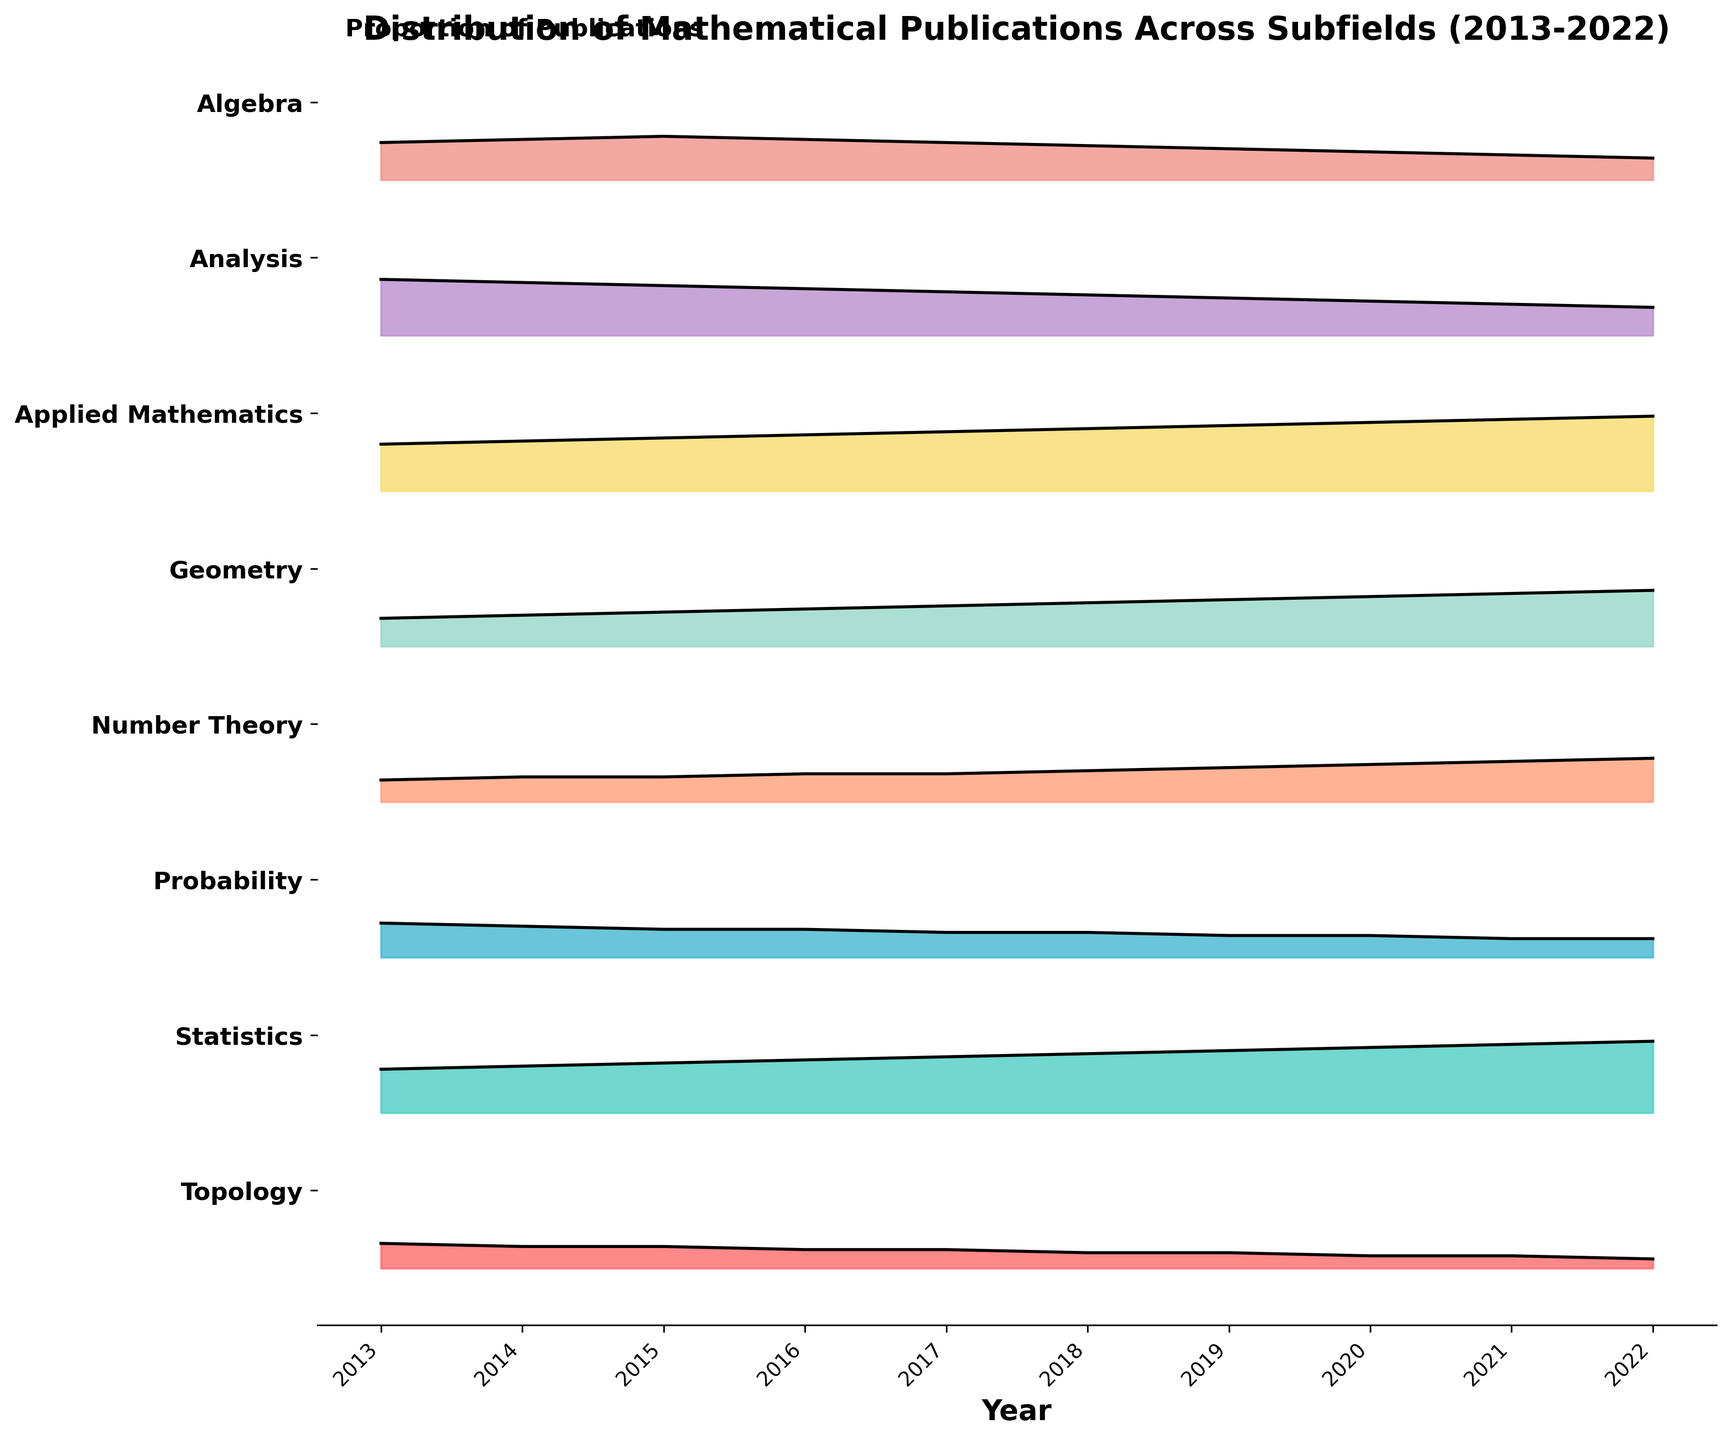What's the title of the plot? The title of the plot is typically displayed at the top of the figure. Here, it is "Distribution of Mathematical Publications Across Subfields (2013-2022)".
Answer: "Distribution of Mathematical Publications Across Subfields (2013-2022)" What are the subfields listed on the y-axis? The y-axis labels generally enumerate the different categories in the plot. Here, the subfields listed from top to bottom are Algebra, Analysis, Applied Mathematics, Geometry, Number Theory, Probability, Statistics, and Topology.
Answer: Algebra, Analysis, Applied Mathematics, Geometry, Number Theory, Probability, Statistics, Topology Which subfield showed a steady increase in the proportion of publications over the years? By carefully observing the trends over the years for each subfield, it becomes apparent that Applied Mathematics exhibited a consistent increase in the proportion of publications from 2013 to 2022.
Answer: Applied Mathematics In which year did Statistics reach its peak proportion of publications? To find the peak proportion of publications for Statistics, look for the year with the highest fill within the corresponding section for Statistics in the plot. That year is 2022.
Answer: 2022 What subfield had the highest proportion of publications in 2014? By examining the peak values for each subfield in 2014, one can see that Analysis had the highest proportion in that year.
Answer: Analysis How does the proportion of publications in Number Theory change from 2013 to 2022? Observing the trend for Number Theory over the depicted years indicates a steady increase. Starting at 0.07 in 2013 and rising incrementally to 0.14 in 2022.
Answer: Steady increase Which subfield had the smallest increase in the proportion of publications from 2013 to 2022? By comparing the differences across the years for each subfield, we notice that Topology saw the least change, starting from 0.08 in 2013 to 0.03 in 2022.
Answer: Topology Compare the trends of Algebra and Geometry over the decade. Assessing the plots for Algebra and Geometry between 2013 to 2022 reveals that Algebra's proportion decreases over time, while Geometry shows a gradual increase.
Answer: Algebra decreases, Geometry increases Which two subfields proportionally matched closest in the year 2020? By examining the values for different fields in 2020, we see that Number Theory and Probability each have a similar proportion, approximately 0.12.
Answer: Number Theory and Probability 